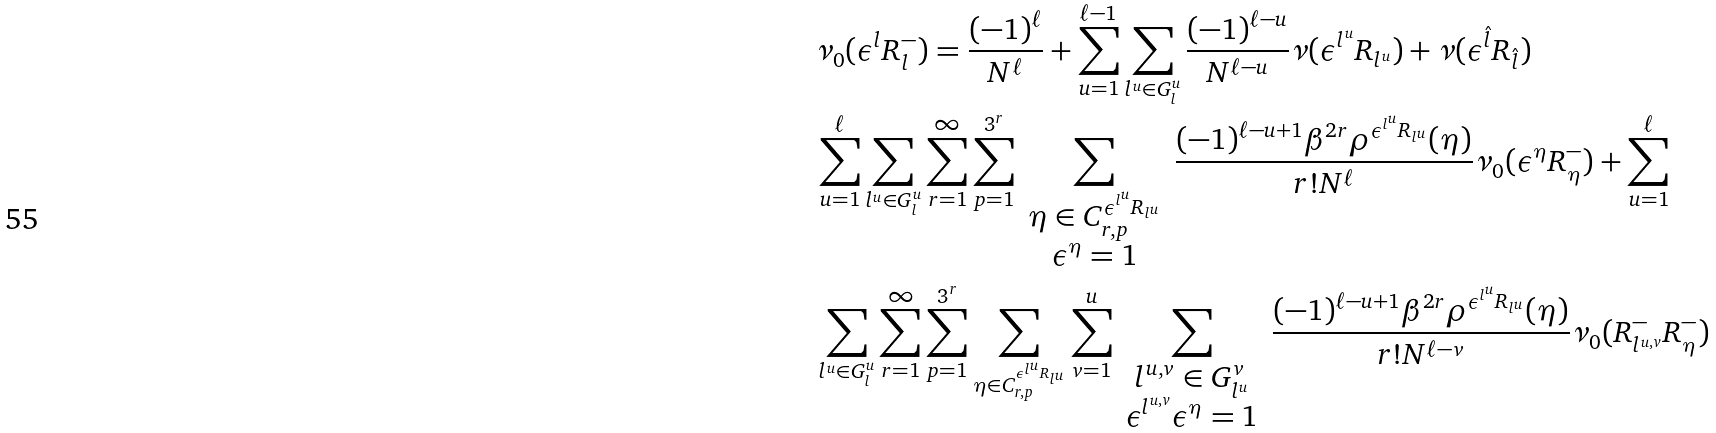<formula> <loc_0><loc_0><loc_500><loc_500>& \nu _ { 0 } ( \epsilon ^ { l } R _ { l } ^ { - } ) = \frac { ( - 1 ) ^ { \ell } } { N ^ { \ell } } + \sum _ { u = 1 } ^ { \ell - 1 } \sum _ { l ^ { u } \in G _ { l } ^ { u } } \frac { ( - 1 ) ^ { \ell - u } } { N ^ { \ell - u } } \nu ( \epsilon ^ { l ^ { u } } R _ { l ^ { u } } ) + \nu ( \epsilon ^ { \hat { l } } R _ { \hat { l } } ) \\ & \sum _ { u = 1 } ^ { \ell } \sum _ { l ^ { u } \in G _ { l } ^ { u } } \sum _ { r = 1 } ^ { \infty } \sum _ { p = 1 } ^ { 3 ^ { r } } \sum _ { \begin{array} { c } \eta \in C ^ { \epsilon ^ { l ^ { u } } R _ { l ^ { u } } } _ { r , p } \\ \epsilon ^ { \eta } = 1 \end{array} } \frac { ( - 1 ) ^ { \ell - u + 1 } \beta ^ { 2 r } \rho ^ { \epsilon ^ { l ^ { u } } R _ { l ^ { u } } } ( \eta ) } { r ! N ^ { \ell } } \nu _ { 0 } ( \epsilon ^ { \eta } R _ { \eta } ^ { - } ) + \sum _ { u = 1 } ^ { \ell } \\ & \sum _ { l ^ { u } \in G _ { l } ^ { u } } \sum ^ { \infty } _ { r = 1 } \sum _ { p = 1 } ^ { 3 ^ { r } } \sum _ { \eta \in C ^ { \epsilon ^ { l ^ { u } } R _ { l ^ { u } } } _ { r , p } } \sum _ { v = 1 } ^ { u } \sum _ { \begin{array} { c } l ^ { u , v } \in G _ { l ^ { u } } ^ { v } \\ \epsilon ^ { l ^ { u , v } } \epsilon ^ { \eta } = 1 \end{array} } \frac { ( - 1 ) ^ { \ell - u + 1 } \beta ^ { 2 r } \rho ^ { \epsilon ^ { l ^ { u } } R _ { l ^ { u } } } ( \eta ) } { r ! N ^ { \ell - v } } \nu _ { 0 } ( R _ { l ^ { u , v } } ^ { - } R _ { \eta } ^ { - } )</formula> 